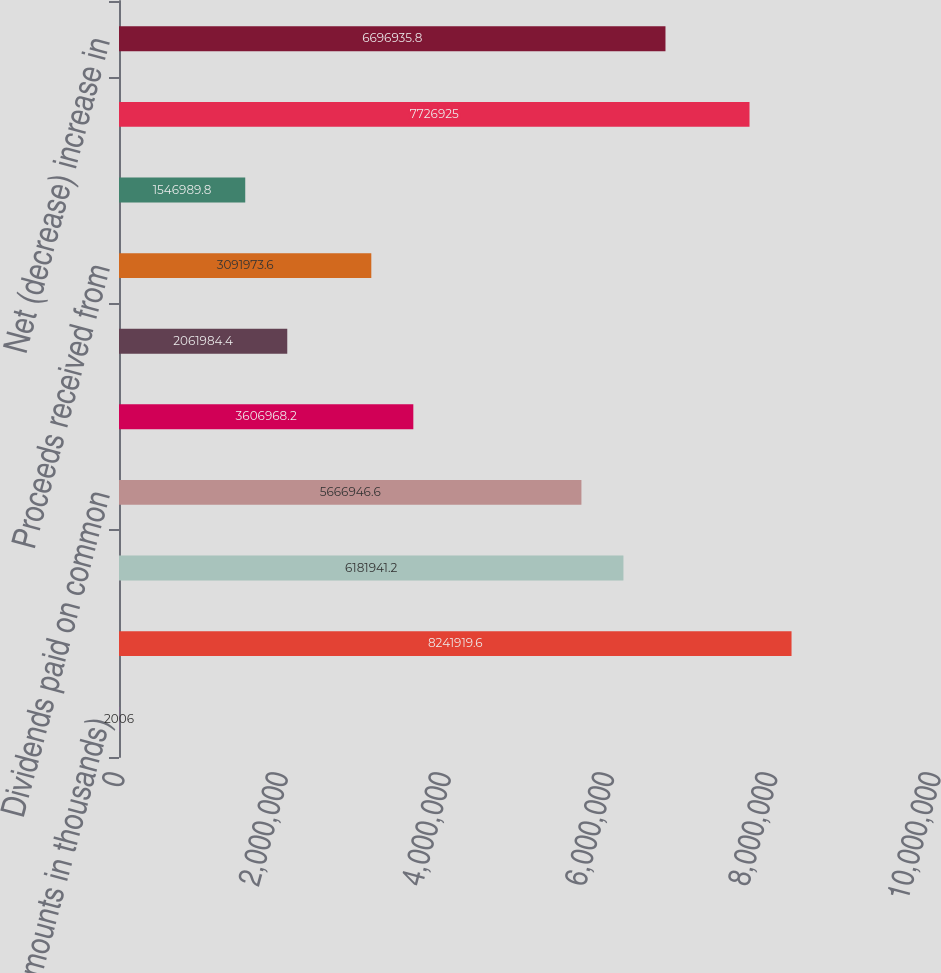Convert chart. <chart><loc_0><loc_0><loc_500><loc_500><bar_chart><fcel>(Amounts in thousands)<fcel>Proceeds from borrowings<fcel>Repayments of borrowings<fcel>Dividends paid on common<fcel>Distributions to minority<fcel>Dividends paid on preferred<fcel>Proceeds received from<fcel>Debt issuance costs<fcel>Net cash provided by financing<fcel>Net (decrease) increase in<nl><fcel>2006<fcel>8.24192e+06<fcel>6.18194e+06<fcel>5.66695e+06<fcel>3.60697e+06<fcel>2.06198e+06<fcel>3.09197e+06<fcel>1.54699e+06<fcel>7.72692e+06<fcel>6.69694e+06<nl></chart> 